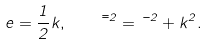Convert formula to latex. <formula><loc_0><loc_0><loc_500><loc_500>e = \frac { 1 } { 2 } k , \quad \bar { \mu } ^ { 2 } = \mu ^ { 2 } + k ^ { 2 } .</formula> 